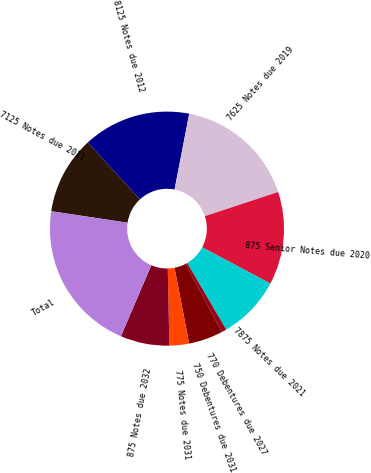<chart> <loc_0><loc_0><loc_500><loc_500><pie_chart><fcel>7125 Notes due 2011<fcel>8125 Notes due 2012<fcel>7625 Notes due 2019<fcel>875 Senior Notes due 2020<fcel>7875 Notes due 2021<fcel>770 Debentures due 2027<fcel>750 Debentures due 2031<fcel>775 Notes due 2031<fcel>875 Notes due 2032<fcel>Total<nl><fcel>10.81%<fcel>14.86%<fcel>16.89%<fcel>12.84%<fcel>8.78%<fcel>0.68%<fcel>4.73%<fcel>2.71%<fcel>6.76%<fcel>20.94%<nl></chart> 